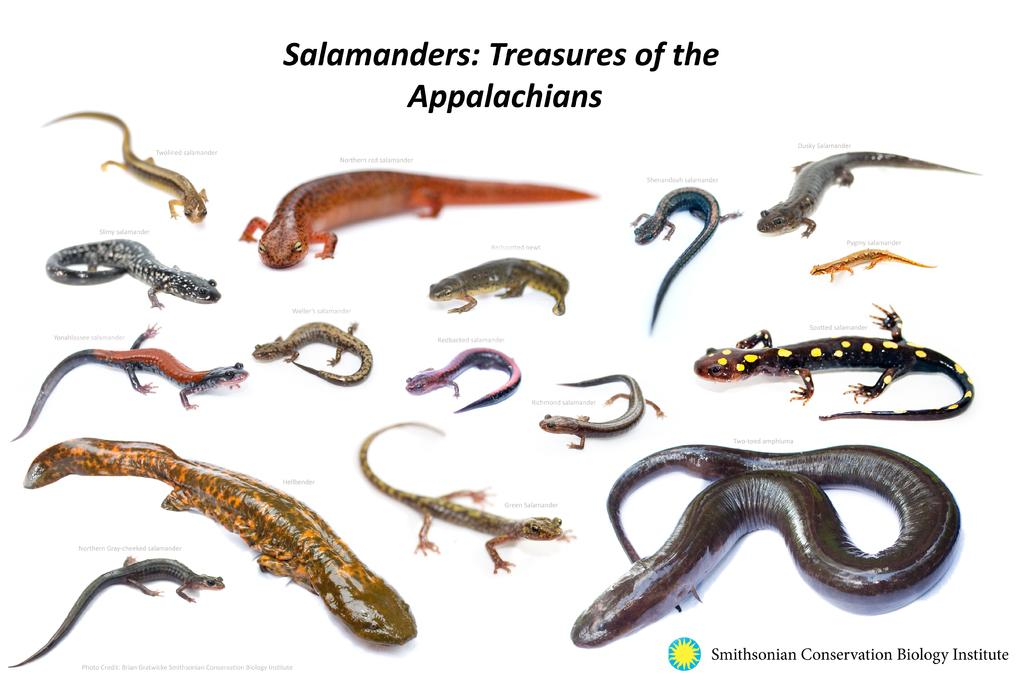What type of animals are depicted in the image? There is a depiction of reptiles in the image. Where can text be found in the image? There is text on the top side and the bottom right side of the image. What is the purpose of the alarm in the image? There is no alarm present in the image; it only features reptiles and text. 